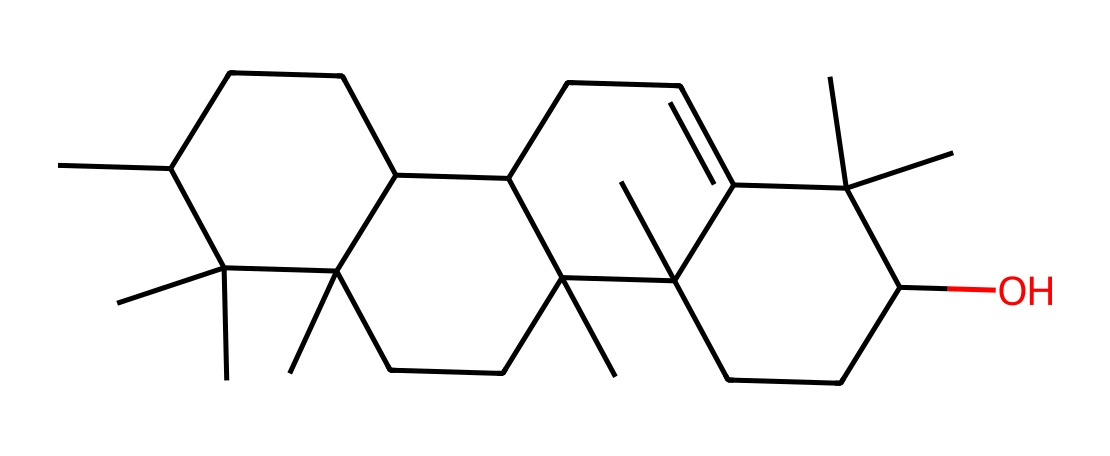How many carbon atoms are in geosmin? By analyzing the SMILES representation, we can count the total carbon atoms represented in the structure. There are 15 carbon atoms indicated by 'C' in the SMILES string.
Answer: 15 What is the molecular formula of geosmin? Looking at the SMILES representation, we can gather that there are 15 carbons and 28 hydrogens. The presence of an oxygen atom in the structure is indicated by 'O'. Therefore, the molecular formula is C15H28O.
Answer: C15H28O How many rings does the geosmin structure have? By examining the SMILES, it is evident that there are two ring structures formed in the sequence. Counting the ring connections, we can confirm that there are two cyclic components in the overall structure.
Answer: 2 Does geosmin contain any double bonds? The SMILES structure contains the notation 'C=C', which indicates the presence of at least one double bond in the molecule, as seen in the segment CCC1(C=...).
Answer: Yes What type of organic compound is geosmin classified as? Geosmin is classified as a sesquiterpene, which is determined by its complex structure that derives from the isoprene units and the presence of multiple carbon rings.
Answer: sesquiterpene What functional group is present in geosmin? The presence of the '-OH' group in the chemical structure indicates that there is a hydroxyl functional group, confirming that geosmin is an alcohol.
Answer: hydroxyl What characteristic odor is geosmin known for? Geosmin is known for its distinct earthy smell, often associated with the scent that is released during or after rain.
Answer: earthy smell 